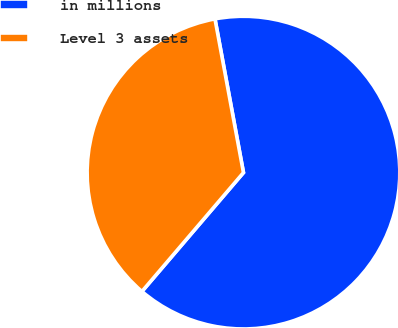Convert chart to OTSL. <chart><loc_0><loc_0><loc_500><loc_500><pie_chart><fcel>in millions<fcel>Level 3 assets<nl><fcel>64.17%<fcel>35.83%<nl></chart> 